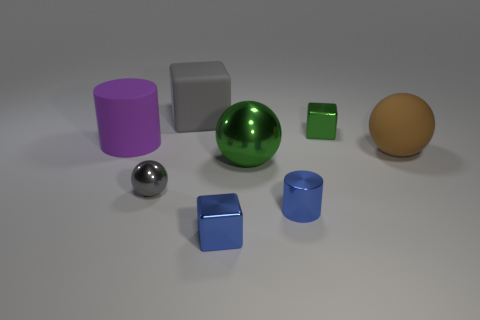Are there fewer small blue metal blocks that are in front of the blue block than gray rubber things that are right of the tiny gray metal object? Upon reviewing the image, we can observe two small blue blocks and three gray objects to the right of the tiny gray metal sphere. Therefore, it is accurate to say that there are fewer small blue blocks in front of the larger blue block than there are gray rubber objects to the right of the tiny gray metal object. 